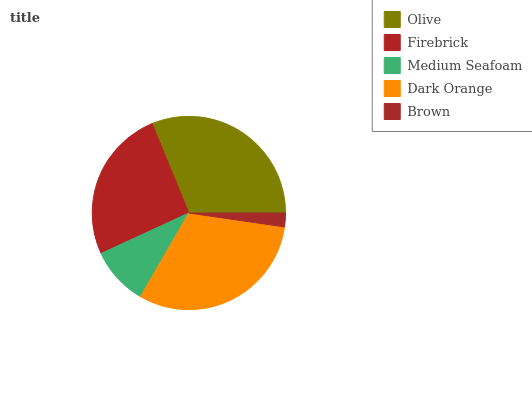Is Brown the minimum?
Answer yes or no. Yes. Is Olive the maximum?
Answer yes or no. Yes. Is Firebrick the minimum?
Answer yes or no. No. Is Firebrick the maximum?
Answer yes or no. No. Is Olive greater than Firebrick?
Answer yes or no. Yes. Is Firebrick less than Olive?
Answer yes or no. Yes. Is Firebrick greater than Olive?
Answer yes or no. No. Is Olive less than Firebrick?
Answer yes or no. No. Is Firebrick the high median?
Answer yes or no. Yes. Is Firebrick the low median?
Answer yes or no. Yes. Is Olive the high median?
Answer yes or no. No. Is Medium Seafoam the low median?
Answer yes or no. No. 